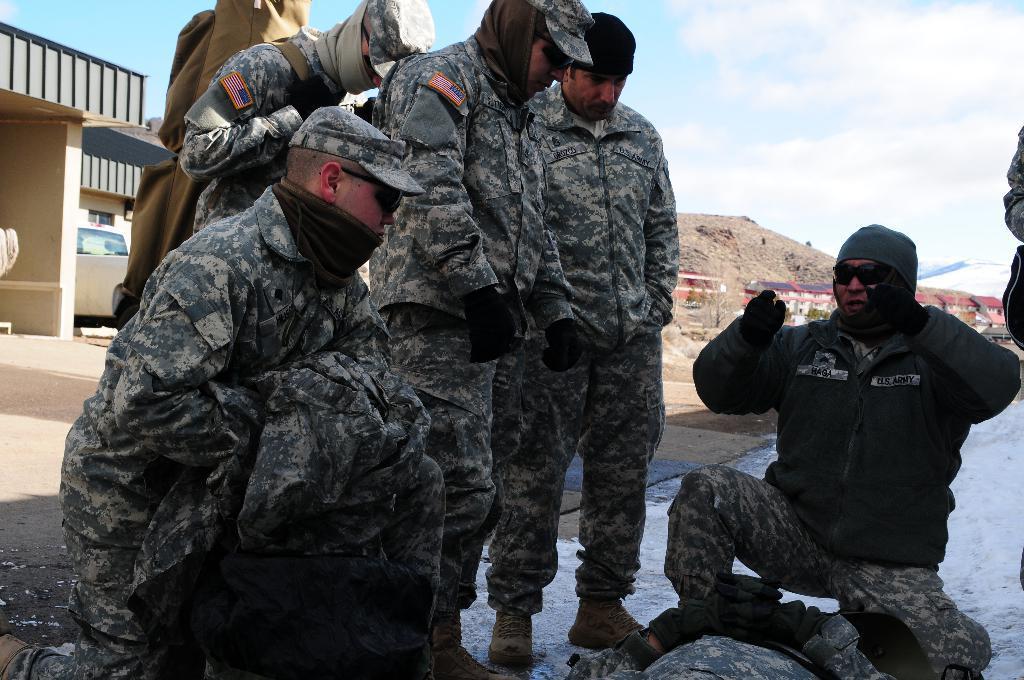In one or two sentences, can you explain what this image depicts? In this image we can see some army officers sitting and some are standing and in the background of the image there are some houses, mountain and top of the image there is cloudy sky. 